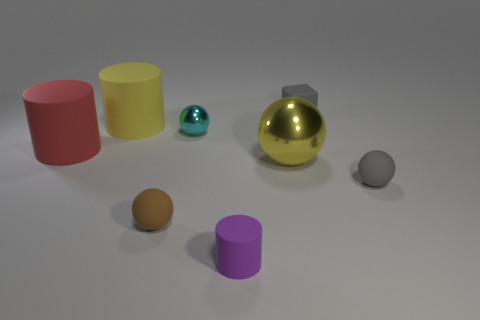Subtract all large cylinders. How many cylinders are left? 1 Subtract 2 spheres. How many spheres are left? 2 Add 1 tiny cyan shiny balls. How many objects exist? 9 Subtract all cyan spheres. How many spheres are left? 3 Subtract all blocks. How many objects are left? 7 Subtract all purple cylinders. Subtract all red spheres. How many cylinders are left? 2 Subtract all blue cubes. How many red balls are left? 0 Subtract all small red balls. Subtract all big yellow balls. How many objects are left? 7 Add 7 large yellow balls. How many large yellow balls are left? 8 Add 6 tiny purple shiny things. How many tiny purple shiny things exist? 6 